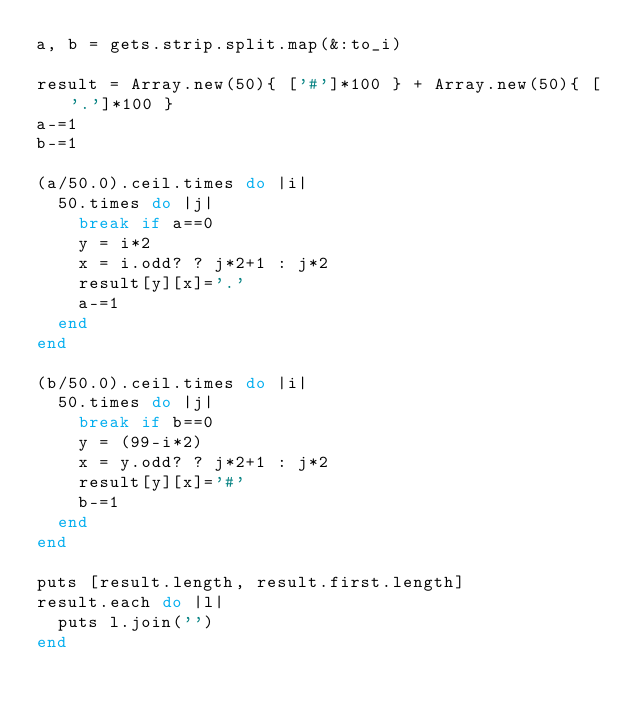Convert code to text. <code><loc_0><loc_0><loc_500><loc_500><_Ruby_>a, b = gets.strip.split.map(&:to_i)

result = Array.new(50){ ['#']*100 } + Array.new(50){ ['.']*100 }
a-=1
b-=1

(a/50.0).ceil.times do |i|
  50.times do |j|
    break if a==0
    y = i*2
    x = i.odd? ? j*2+1 : j*2
    result[y][x]='.'
    a-=1
  end
end

(b/50.0).ceil.times do |i|
  50.times do |j|
    break if b==0
    y = (99-i*2)
    x = y.odd? ? j*2+1 : j*2
    result[y][x]='#'
    b-=1
  end
end

puts [result.length, result.first.length]
result.each do |l|
  puts l.join('')
end


</code> 